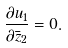<formula> <loc_0><loc_0><loc_500><loc_500>\frac { \partial u _ { 1 } } { \partial \bar { z } _ { 2 } } = 0 .</formula> 